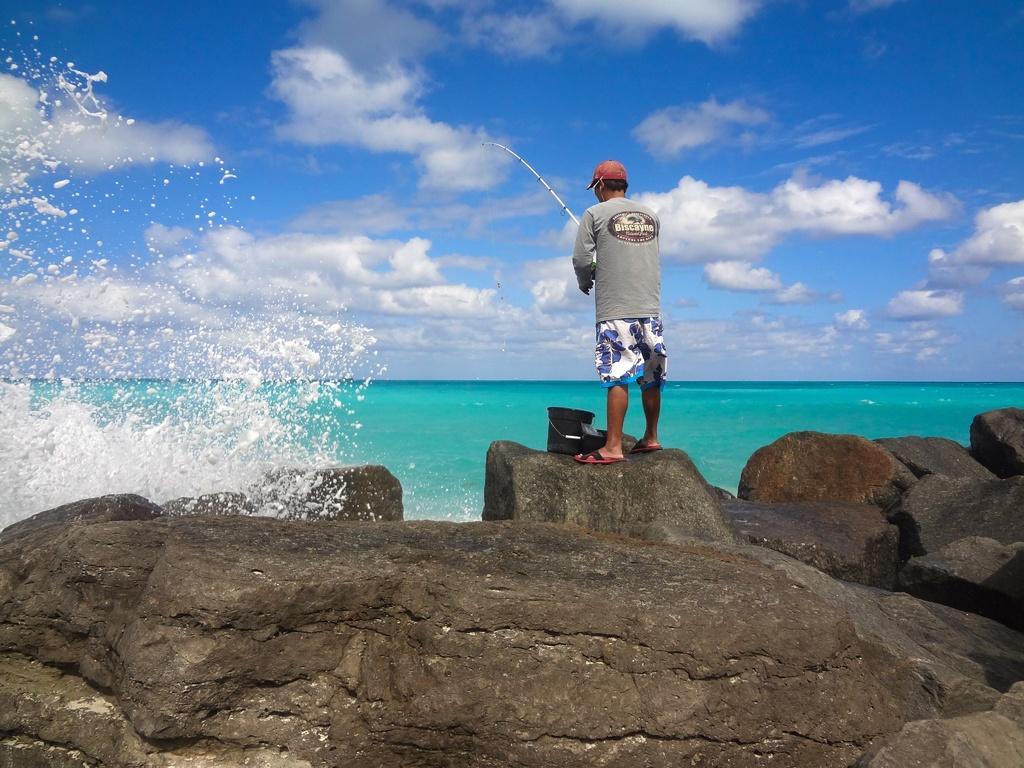How would you summarize this image in a sentence or two? In this picture we can see a person standing on a rock, he is holding a fishing rod, here we can see rocks, bucket and some objects and in the background we can see water and sky with clouds. 